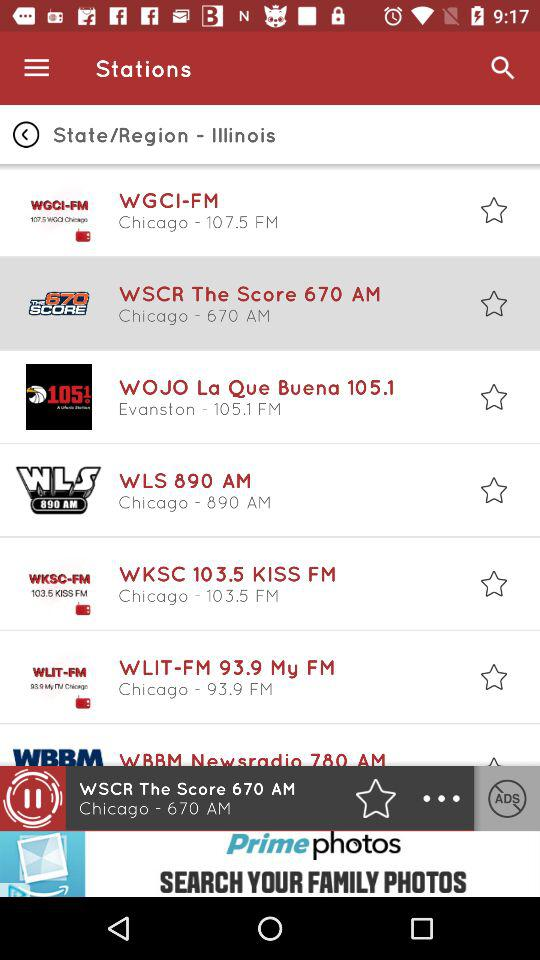What is the geographical location of "WOJO La Que Buena 105.1"?of "WOJO La Que Buena 105.1"? The geographical location is Evanston. 